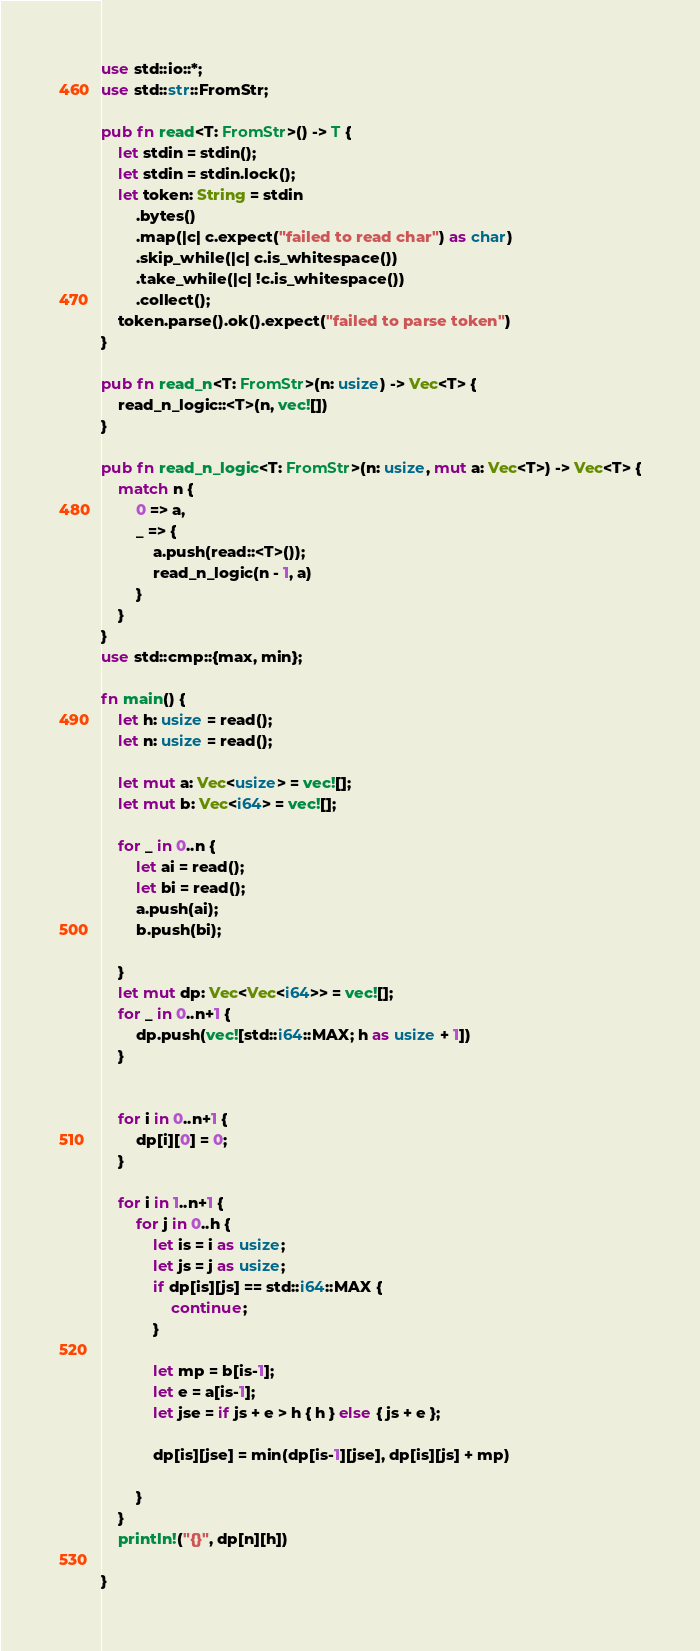Convert code to text. <code><loc_0><loc_0><loc_500><loc_500><_Rust_>use std::io::*;
use std::str::FromStr;

pub fn read<T: FromStr>() -> T {
    let stdin = stdin();
    let stdin = stdin.lock();
    let token: String = stdin
        .bytes()
        .map(|c| c.expect("failed to read char") as char)
        .skip_while(|c| c.is_whitespace())
        .take_while(|c| !c.is_whitespace())
        .collect();
    token.parse().ok().expect("failed to parse token")
}

pub fn read_n<T: FromStr>(n: usize) -> Vec<T> {
    read_n_logic::<T>(n, vec![])
}

pub fn read_n_logic<T: FromStr>(n: usize, mut a: Vec<T>) -> Vec<T> {
    match n {
        0 => a,
        _ => {
            a.push(read::<T>());
            read_n_logic(n - 1, a)
        }
    }
}
use std::cmp::{max, min};

fn main() {
    let h: usize = read();
    let n: usize = read();

    let mut a: Vec<usize> = vec![];
    let mut b: Vec<i64> = vec![];

    for _ in 0..n {
        let ai = read();
        let bi = read();
        a.push(ai);
        b.push(bi);

    }
    let mut dp: Vec<Vec<i64>> = vec![];
    for _ in 0..n+1 {
        dp.push(vec![std::i64::MAX; h as usize + 1])
    }


    for i in 0..n+1 {
        dp[i][0] = 0;
    }

    for i in 1..n+1 {
        for j in 0..h {
            let is = i as usize;
            let js = j as usize;
            if dp[is][js] == std::i64::MAX {
                continue;
            } 

            let mp = b[is-1];
            let e = a[is-1];
            let jse = if js + e > h { h } else { js + e };

            dp[is][jse] = min(dp[is-1][jse], dp[is][js] + mp)
        
        }
    }
    println!("{}", dp[n][h])

}
</code> 